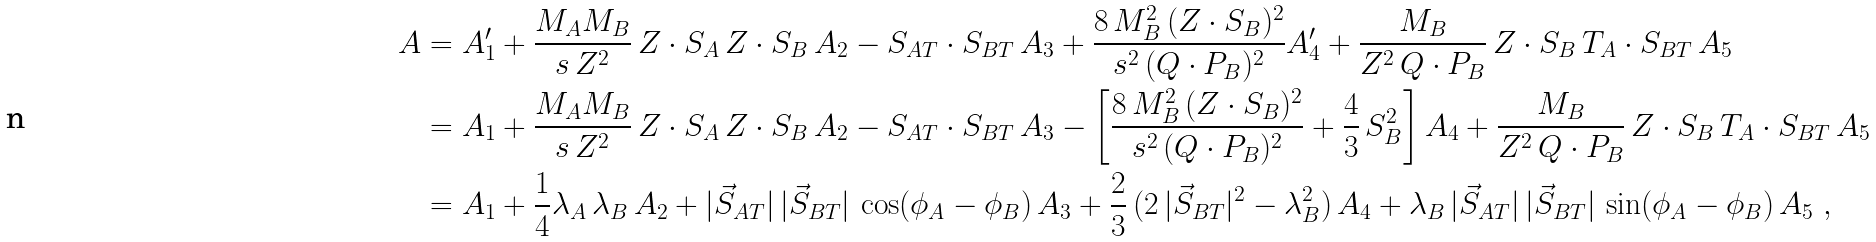<formula> <loc_0><loc_0><loc_500><loc_500>A & = A _ { 1 } ^ { \prime } + \frac { M _ { A } M _ { B } } { s \, Z ^ { 2 } } \, Z \cdot S _ { A } \, Z \cdot S _ { B } \, A _ { 2 } - S _ { A T } \cdot S _ { B T } \, A _ { 3 } + \frac { 8 \, M _ { B } ^ { 2 } \, ( Z \cdot S _ { B } ) ^ { 2 } } { s ^ { 2 } \, ( Q \cdot P _ { B } ) ^ { 2 } } A _ { 4 } ^ { \prime } + \frac { M _ { B } } { Z ^ { 2 } \, Q \cdot P _ { B } } \, Z \cdot S _ { B } \, T _ { A } \cdot S _ { B T } \, A _ { 5 } \\ & = A _ { 1 } + \frac { M _ { A } M _ { B } } { s \, Z ^ { 2 } } \, Z \cdot S _ { A } \, Z \cdot S _ { B } \, A _ { 2 } - S _ { A T } \cdot S _ { B T } \, A _ { 3 } - \left [ \frac { 8 \, M _ { B } ^ { 2 } \, ( Z \cdot S _ { B } ) ^ { 2 } } { s ^ { 2 } \, ( Q \cdot P _ { B } ) ^ { 2 } } + \frac { 4 } { 3 } \, S _ { B } ^ { 2 } \right ] A _ { 4 } + \frac { M _ { B } } { Z ^ { 2 } \, Q \cdot P _ { B } } \, Z \cdot S _ { B } \, T _ { A } \cdot S _ { B T } \, A _ { 5 } \\ & = A _ { 1 } + \frac { 1 } { 4 } \lambda _ { A } \, \lambda _ { B } \, A _ { 2 } + | \vec { S } _ { A T } | \, | \vec { S } _ { B T } | \, \cos ( \phi _ { A } - \phi _ { B } ) \, A _ { 3 } + \frac { 2 } { 3 } \, ( 2 \, | \vec { S } _ { B T } | ^ { 2 } - \lambda _ { B } ^ { 2 } ) \, A _ { 4 } + \lambda _ { B } \, | \vec { S } _ { A T } | \, | \vec { S } _ { B T } | \, \sin ( \phi _ { A } - \phi _ { B } ) \, A _ { 5 } \ ,</formula> 